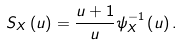Convert formula to latex. <formula><loc_0><loc_0><loc_500><loc_500>S _ { X } \left ( u \right ) = \frac { u + 1 } { u } \psi _ { X } ^ { - 1 } \left ( u \right ) .</formula> 